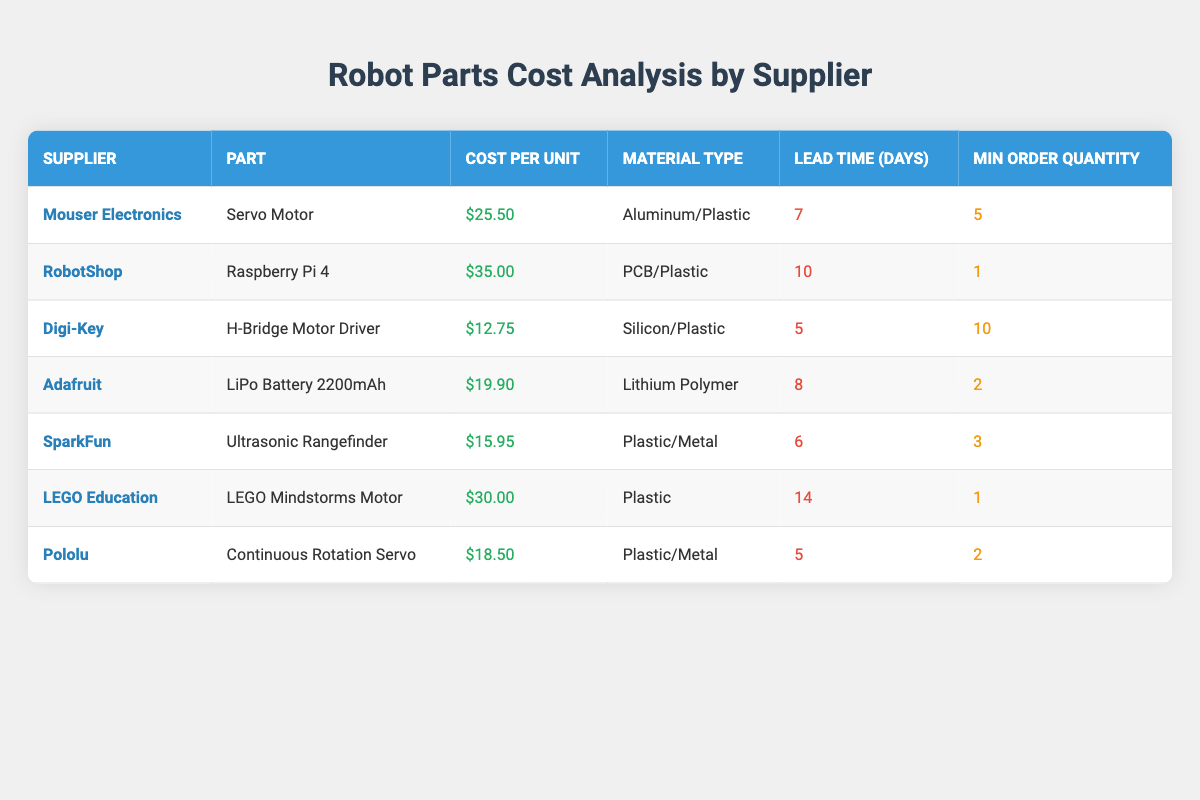What is the cost per unit of the Servo Motor from Mouser Electronics? The table explicitly lists the cost per unit for the Servo Motor from Mouser Electronics as $25.50.
Answer: $25.50 Which supplier offers the Ultrasonic Rangefinder? The table specifies that the Ultrasonic Rangefinder is offered by SparkFun.
Answer: SparkFun What is the total cost of ordering the minimum quantity of Raspberry Pi 4 from RobotShop? The cost per unit for the Raspberry Pi 4 is $35.00 and the minimum order quantity is 1, so the total cost is 35.00 * 1 = $35.00.
Answer: $35.00 Is the material type for the LiPo Battery 2200mAh Lithium Polymer? The table indicates that the material type for the LiPo Battery 2200mAh from Adafruit is indeed Lithium Polymer.
Answer: Yes What supplier has the longest lead time, and what is that lead time? The table shows that LEGO Education has the longest lead time of 14 days for the LEGO Mindstorms Motor.
Answer: LEGO Education, 14 days If I want to order two Continuous Rotation Servos from Pololu and one H-Bridge Motor Driver from Digi-Key, what will be the total cost? The cost for two Continuous Rotation Servos from Pololu is 18.50 * 2 = 37.00, and for one H-Bridge Motor Driver from Digi-Key, it is 12.75. The total cost is 37.00 + 12.75 = 49.75.
Answer: $49.75 How many suppliers offer parts made with Plastic/Metal material? The table lists two parts made with Plastic/Metal: the Ultrasonic Rangefinder from SparkFun and the Continuous Rotation Servo from Pololu. Therefore, two suppliers offer parts with this material.
Answer: 2 What is the average cost per unit of all the parts listed in the table? Summing the costs (25.50 + 35.00 + 12.75 + 19.90 + 15.95 + 30.00 + 18.50) gives a total of 126.60. With 7 parts in total, the average cost is 126.60 / 7 ≈ 18.09.
Answer: $18.09 Which suppliers offer a minimum order quantity of just 1? According to the table, both RobotShop (for Raspberry Pi 4) and LEGO Education (for LEGO Mindstorms Motor) require a minimum order quantity of 1.
Answer: RobotShop and LEGO Education 